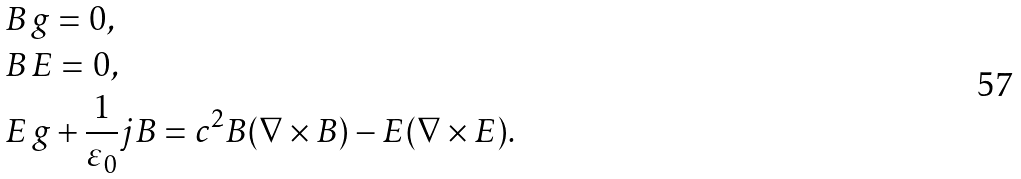<formula> <loc_0><loc_0><loc_500><loc_500>& B \, g = 0 , \\ & B \, E = 0 , \\ & E \, g + \frac { 1 } { \varepsilon _ { 0 } } j B = c ^ { 2 } B ( \nabla \times B ) - E ( \nabla \times E ) .</formula> 